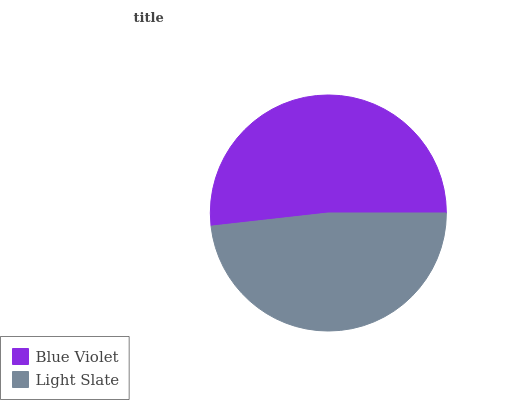Is Light Slate the minimum?
Answer yes or no. Yes. Is Blue Violet the maximum?
Answer yes or no. Yes. Is Light Slate the maximum?
Answer yes or no. No. Is Blue Violet greater than Light Slate?
Answer yes or no. Yes. Is Light Slate less than Blue Violet?
Answer yes or no. Yes. Is Light Slate greater than Blue Violet?
Answer yes or no. No. Is Blue Violet less than Light Slate?
Answer yes or no. No. Is Blue Violet the high median?
Answer yes or no. Yes. Is Light Slate the low median?
Answer yes or no. Yes. Is Light Slate the high median?
Answer yes or no. No. Is Blue Violet the low median?
Answer yes or no. No. 